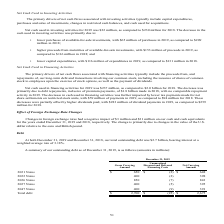According to Activision Blizzard's financial document, What was the company's outstanding debt At both December 31, 2019 and December 31, 2018? According to the financial document, $2.7 billion (in billions). The relevant text states: "December 31, 2018, our total outstanding debt was $2.7 billion, bearing interest at a..." Also, What was the gross carrying amount in the 2021 Notes? According to the financial document, $650 (in millions). The relevant text states: "2021 Notes $ 650 $ (2) $ 648..." Also, What was the gross carrying amount in the 2022 Notes? According to the financial document, 400 (in millions). The relevant text states: "2022 Notes 400 (2) 398..." Also, can you calculate: What was the change in gross carrying amount between the 2021 and 2022 Notes? Based on the calculation: (650-400), the result is 250 (in millions). This is based on the information: "2022 Notes 400 (2) 398 2021 Notes $ 650 $ (2) $ 648..." The key data points involved are: 400, 650. Also, can you calculate: What is the sum of the 2 highest gross carrying amounts? Based on the calculation: (850+650), the result is 1500 (in millions). This is based on the information: "2026 Notes 850 (7) 843 2021 Notes $ 650 $ (2) $ 648..." The key data points involved are: 650, 850. Also, can you calculate: What is the percentage change in the net carrying amount between the 2022 Notes and 2026 Notes? To answer this question, I need to perform calculations using the financial data. The calculation is: (843-398)/398, which equals 111.81 (percentage). This is based on the information: "2026 Notes 850 (7) 843 2022 Notes 400 (2) 398..." The key data points involved are: 398, 843. 